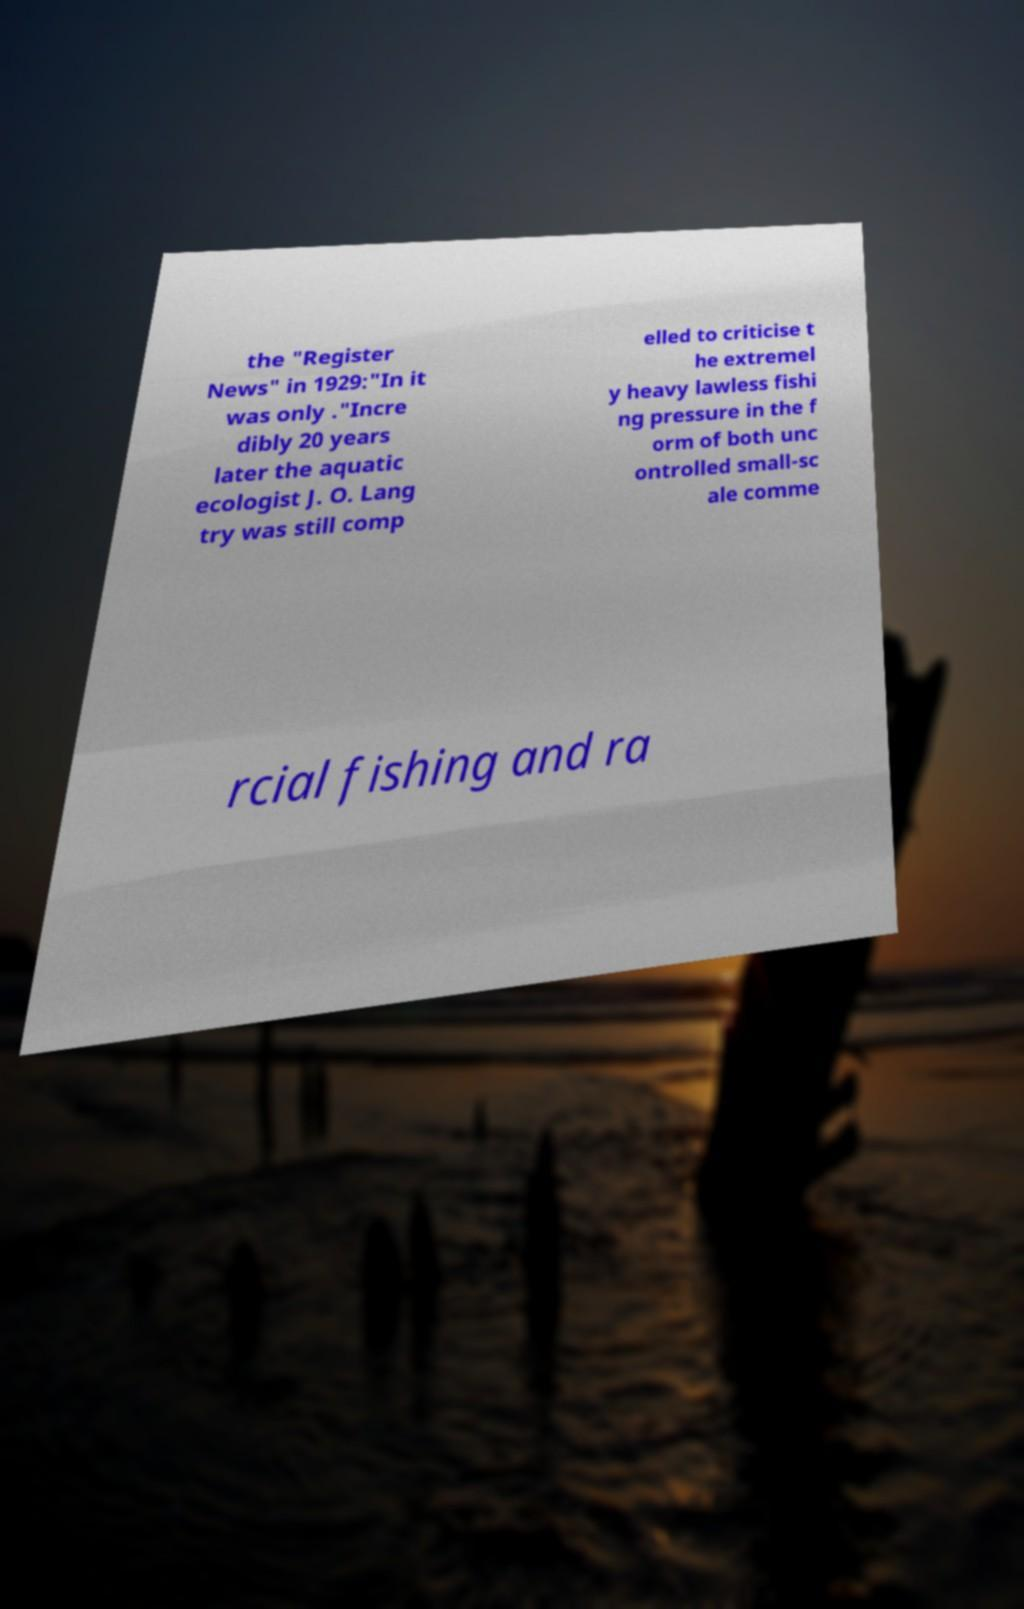I need the written content from this picture converted into text. Can you do that? the "Register News" in 1929:"In it was only ."Incre dibly 20 years later the aquatic ecologist J. O. Lang try was still comp elled to criticise t he extremel y heavy lawless fishi ng pressure in the f orm of both unc ontrolled small-sc ale comme rcial fishing and ra 